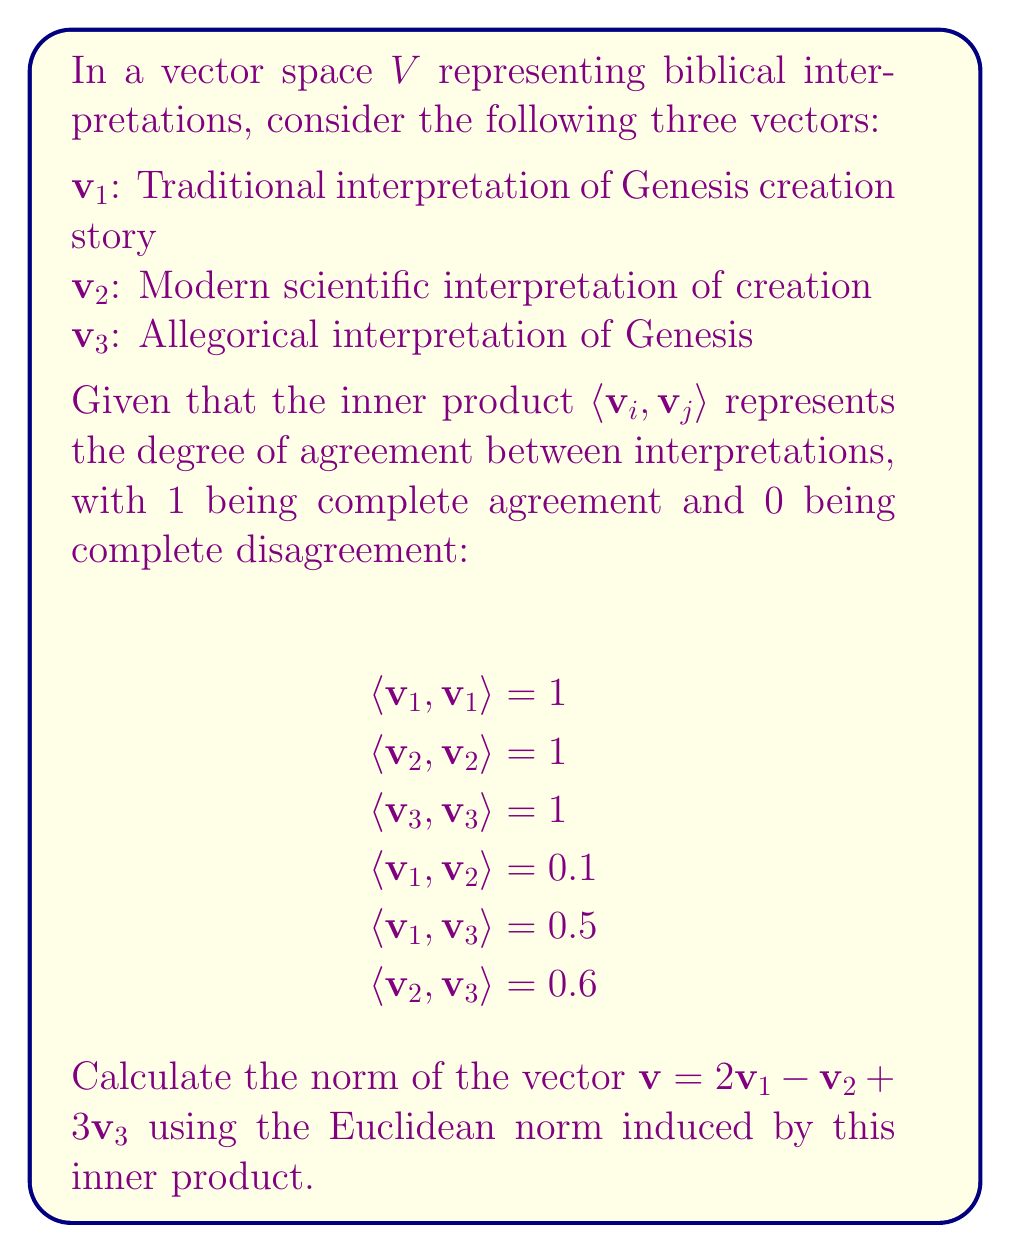Give your solution to this math problem. To calculate the norm of vector $v = 2v_1 - v_2 + 3v_3$, we'll use the formula:

$$\|v\| = \sqrt{\langle v, v \rangle}$$

First, let's expand $\langle v, v \rangle$:

$$\langle v, v \rangle = \langle 2v_1 - v_2 + 3v_3, 2v_1 - v_2 + 3v_3 \rangle$$

Using the properties of inner products:

$$\begin{align*}
\langle v, v \rangle &= 4\langle v_1, v_1 \rangle + \langle v_2, v_2 \rangle + 9\langle v_3, v_3 \rangle \\
&- 4\langle v_1, v_2 \rangle + 12\langle v_1, v_3 \rangle - 6\langle v_2, v_3 \rangle
\end{align*}$$

Now, let's substitute the given values:

$$\begin{align*}
\langle v, v \rangle &= 4(1) + 1(1) + 9(1) \\
&- 4(0.1) + 12(0.5) - 6(0.6) \\
&= 4 + 1 + 9 - 0.4 + 6 - 3.6 \\
&= 16
\end{align*}$$

Finally, we can calculate the norm:

$$\|v\| = \sqrt{\langle v, v \rangle} = \sqrt{16} = 4$$
Answer: $\|v\| = 4$ 